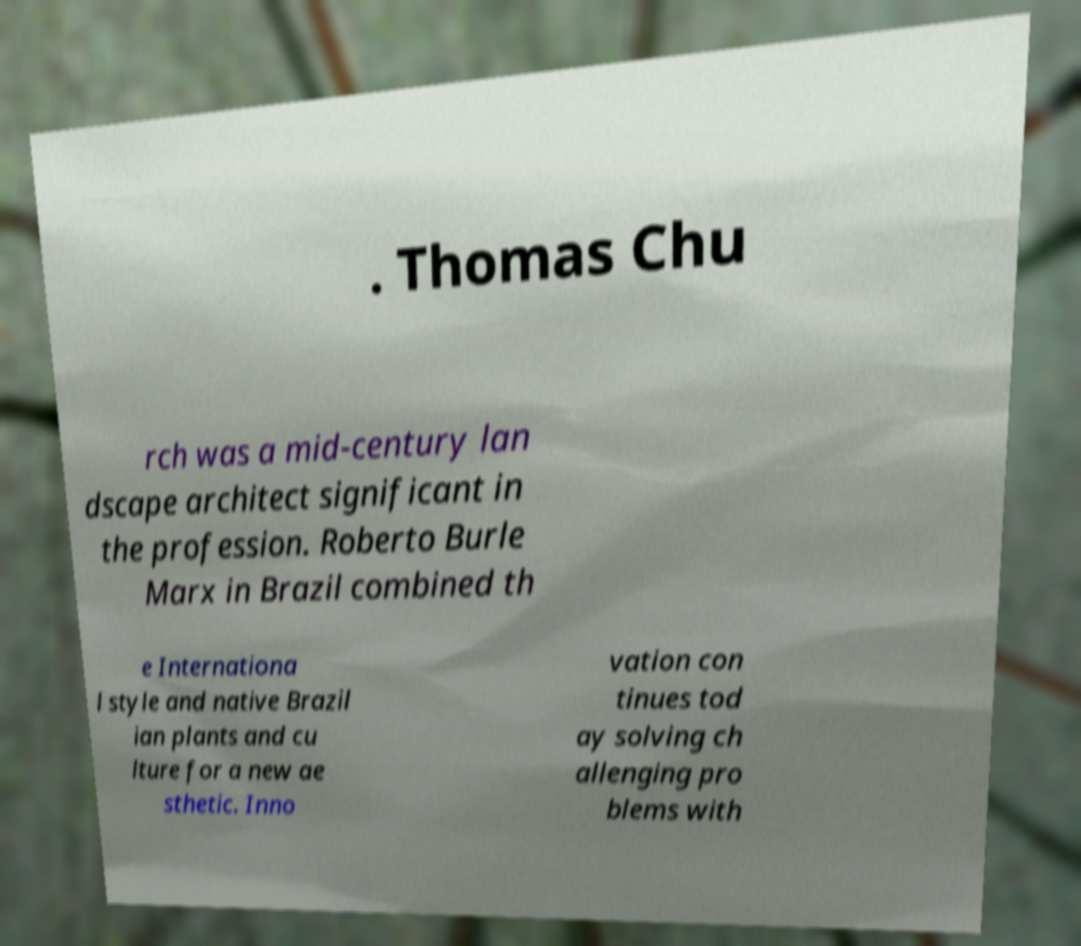There's text embedded in this image that I need extracted. Can you transcribe it verbatim? . Thomas Chu rch was a mid-century lan dscape architect significant in the profession. Roberto Burle Marx in Brazil combined th e Internationa l style and native Brazil ian plants and cu lture for a new ae sthetic. Inno vation con tinues tod ay solving ch allenging pro blems with 